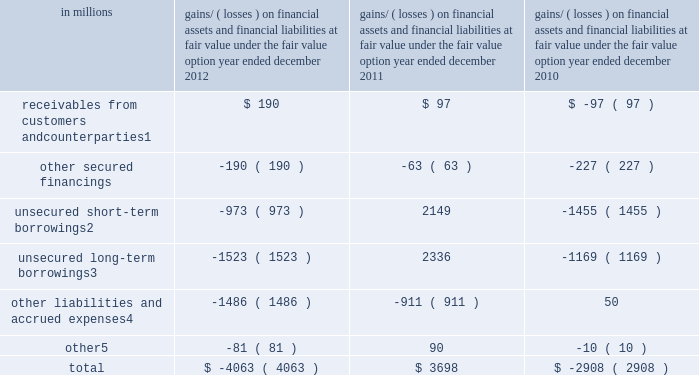Notes to consolidated financial statements gains and losses on financial assets and financial liabilities accounted for at fair value under the fair value option the table below presents the gains and losses recognized as a result of the firm electing to apply the fair value option to certain financial assets and financial liabilities .
These gains and losses are included in 201cmarket making 201d and 201cother principal transactions . 201d the table below also includes gains and losses on the embedded derivative component of hybrid financial instruments included in unsecured short-term borrowings and unsecured long-term borrowings .
These gains and losses would have been recognized under other u.s .
Gaap even if the firm had not elected to account for the entire hybrid instrument at fair value .
The amounts in the table exclude contractual interest , which is included in 201cinterest income 201d and 201cinterest expense , 201d for all instruments other than hybrid financial instruments .
See note 23 for further information about interest income and interest expense .
Gains/ ( losses ) on financial assets and financial liabilities at fair value under the fair value option year ended december in millions 2012 2011 2010 receivables from customers and counterparties 1 $ 190 $ 97 $ ( 97 ) .
Primarily consists of gains/ ( losses ) on certain reinsurance contracts and certain transfers accounted for as receivables rather than purchases .
Includes gains/ ( losses ) on the embedded derivative component of hybrid financial instruments of $ ( 814 ) million , $ 2.01 billion , and $ ( 1.49 ) billion as of december 2012 , december 2011 and december 2010 , respectively .
Includes gains/ ( losses ) on the embedded derivative component of hybrid financial instruments of $ ( 887 ) million , $ 1.80 billion and $ ( 1.32 ) billion as of december 2012 , december 2011 and december 2010 , respectively .
Primarily consists of gains/ ( losses ) on certain insurance contracts .
Primarily consists of gains/ ( losses ) on resale and repurchase agreements , securities borrowed and loaned and deposits .
Excluding the gains and losses on the instruments accounted for under the fair value option described above , 201cmarket making 201d and 201cother principal transactions 201d primarily represent gains and losses on 201cfinancial instruments owned , at fair value 201d and 201cfinancial instruments sold , but not yet purchased , at fair value . 201d 150 goldman sachs 2012 annual report .
By what amount is the total gains/ ( losses ) on financial assets and financial liabilities at fair value at 2018 different from 2017? 
Computations: (-4063 - 3698)
Answer: -7761.0. 